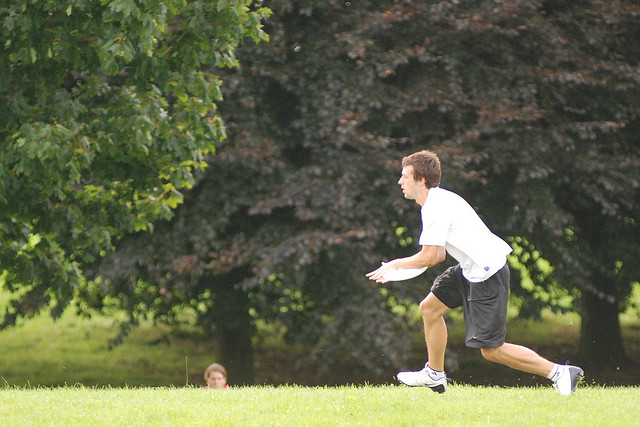Is there anyone else in the image besides the main subject? Yes, there appears to be another individual in the background. They are not as easily noticed due to their smaller size in the frame and the distance from the camera, implying they may be further back in the park. What might the relationship be between the two individuals? It's difficult to determine their relationship with certainty from this single image alone. However, given the recreational context and their presence in the same area, they could be friends, family, or acquaintances engaged in a shared activity, such as playing a game or simply enjoying a day at the park together. 